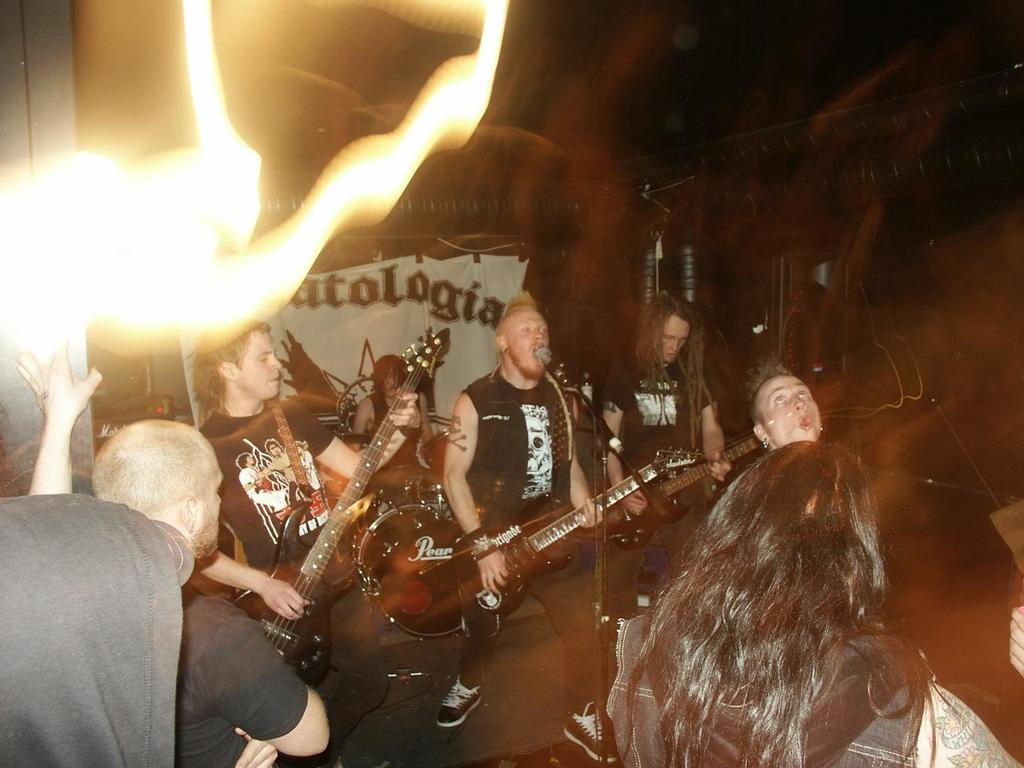What are the people in the image doing? The people in the image are playing guitar and singing. What object is present in front of the people? There is a microphone in front of the people. Can you hear the thunder in the background while the people are singing? There is no mention of thunder in the image, so it cannot be heard in the background. 